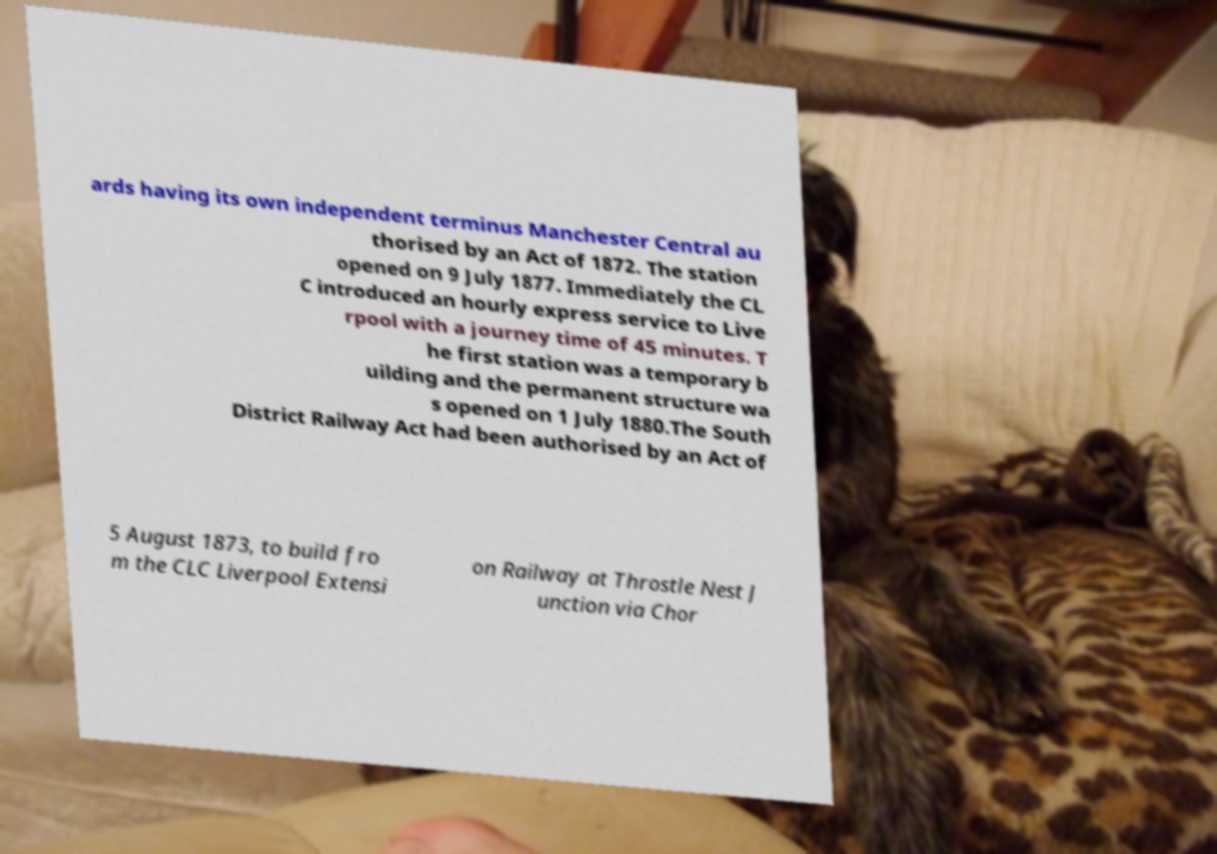Can you accurately transcribe the text from the provided image for me? ards having its own independent terminus Manchester Central au thorised by an Act of 1872. The station opened on 9 July 1877. Immediately the CL C introduced an hourly express service to Live rpool with a journey time of 45 minutes. T he first station was a temporary b uilding and the permanent structure wa s opened on 1 July 1880.The South District Railway Act had been authorised by an Act of 5 August 1873, to build fro m the CLC Liverpool Extensi on Railway at Throstle Nest J unction via Chor 